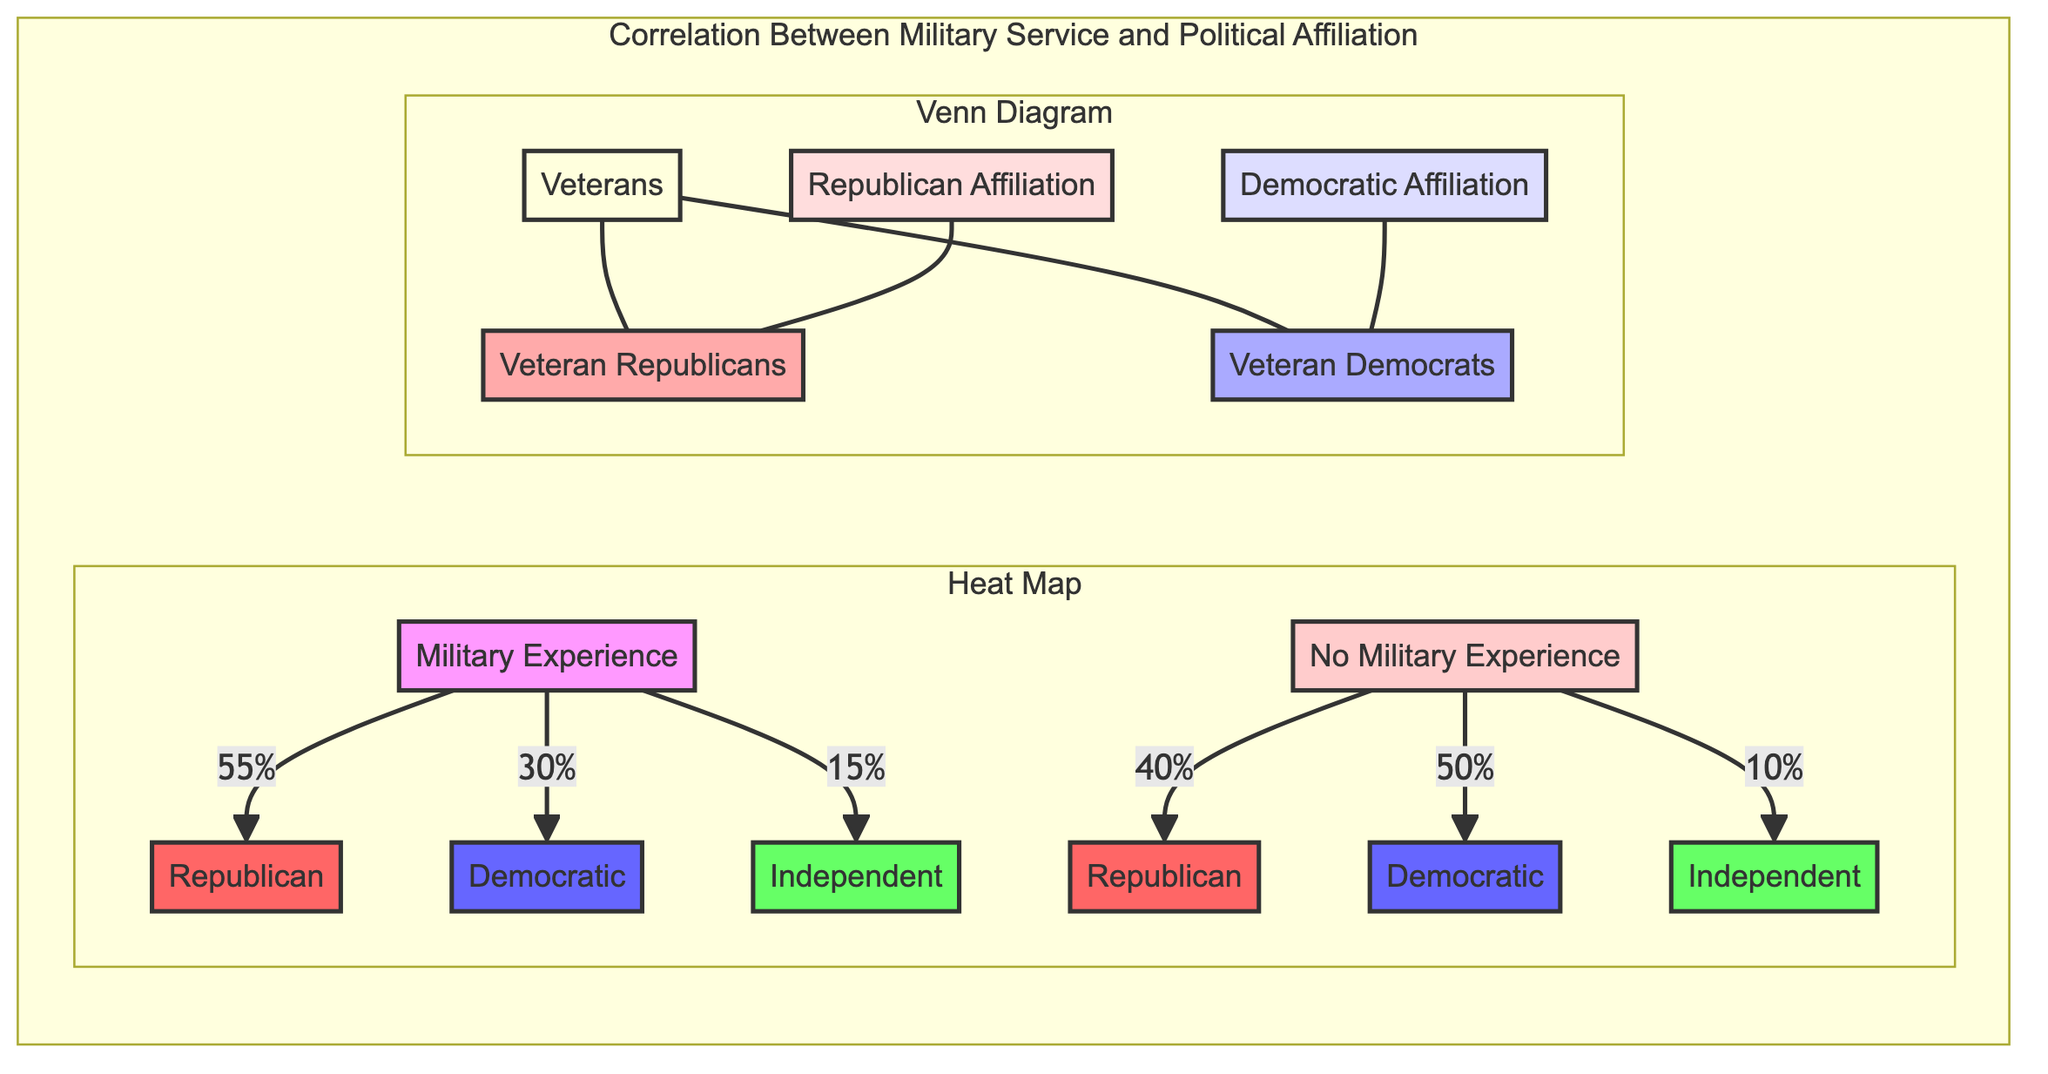What percentage of military experience respondents identify as Republican? According to the heat map, 55% of respondents with military experience identify as Republican. This can be directly read from the arrow leading from the "Military Experience" node to the "Republican" node, which indicates the percentage.
Answer: 55% What is the percentage of independent affiliation for those with no military experience? The heat map shows that 10% of individuals with no military experience identify as Independent. This is noted on the arrow from the "No Military Experience" node to the "Independent" node.
Answer: 10% How many categories are there in the Venn Diagram? The Venn Diagram includes five distinct categories: Veterans, Republican Affiliation, Democratic Affiliation, Veteran Republicans, and Veteran Democrats. Counting all the labeled nodes gives the total.
Answer: 5 What is the relationship between veterans and veteran Republicans? The diagram visually connects "Veterans" and "Veteran Republicans" with a direct line, indicating a subset relationship where veteran Republicans are a part of the larger group of Veterans.
Answer: Subset How do the percentages of Democrats in military experience and no military experience compare? For military experience, the percentage of Democrats is 30%, while it is 50% for no military experience. This comparison can be done by looking at their respective values in the heat map, and calculating that 50% exceeds 30%.
Answer: 50% > 30% What is the total percentage of non-Republican affiliations for those with military experience? The percentages for Democrats and Independents among military experience respondents are 30% and 15%, respectively. By adding these two percentages together (30% + 15%), we find the total percentage of non-Republican affiliations.
Answer: 45% What colors represent the nodes of Republican and Democratic Affiliation? The "Republican Affiliation" node is represented in a light red hue (#fdd) and The "Democratic Affiliation" node is colored in light blue (#ddf). These colors can be identified by looking at the styling definitions associated with these nodes in the diagram.
Answer: Light red and light blue Which group has a smaller percentage among those with military experience: Democrats or Independents? The heat map indicates that Independents represent 15% of individuals with military experience, whereas Democrats account for 30%. Comparing these two values shows that 15% is smaller.
Answer: Independents 